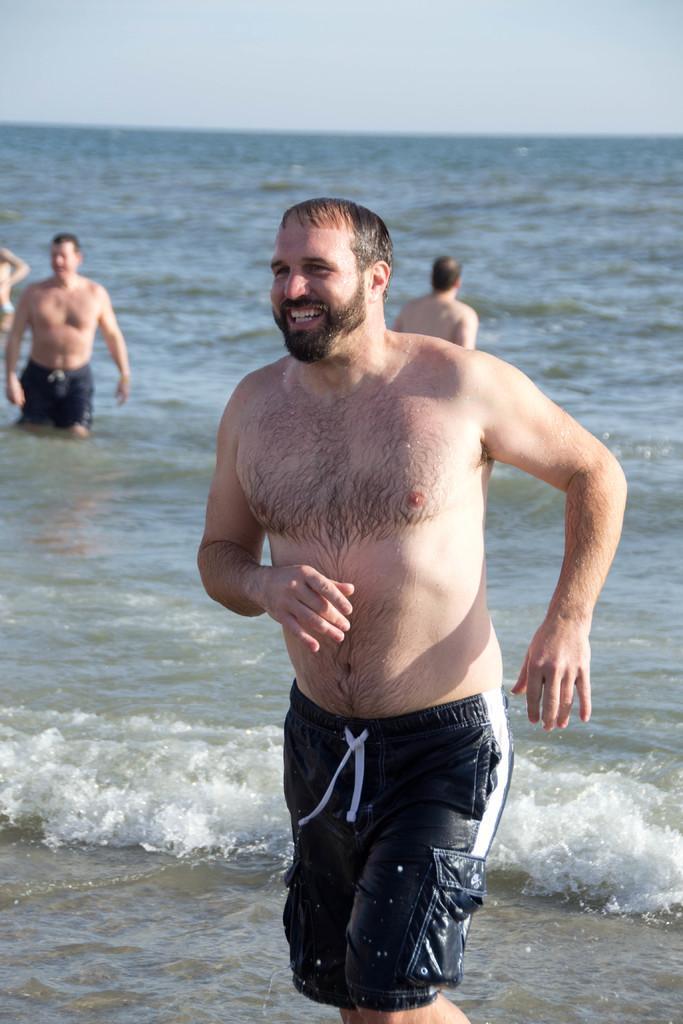How would you summarize this image in a sentence or two? This picture shows couple of men standing in the water. we see a smile on the face of a man and a cloudy sky. 